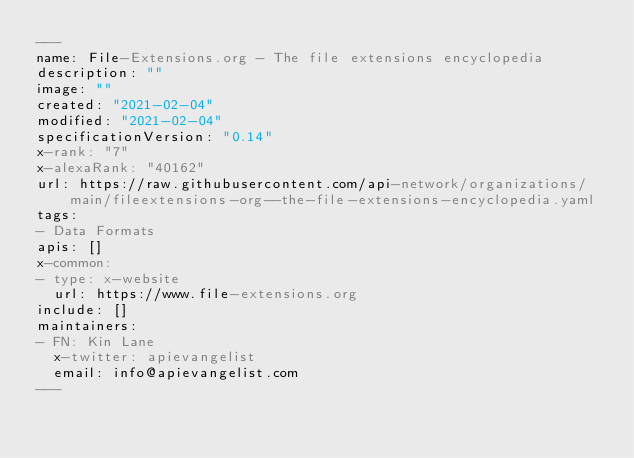<code> <loc_0><loc_0><loc_500><loc_500><_YAML_>---
name: File-Extensions.org - The file extensions encyclopedia
description: ""
image: ""
created: "2021-02-04"
modified: "2021-02-04"
specificationVersion: "0.14"
x-rank: "7"
x-alexaRank: "40162"
url: https://raw.githubusercontent.com/api-network/organizations/main/fileextensions-org--the-file-extensions-encyclopedia.yaml
tags:
- Data Formats
apis: []
x-common:
- type: x-website
  url: https://www.file-extensions.org
include: []
maintainers:
- FN: Kin Lane
  x-twitter: apievangelist
  email: info@apievangelist.com
---</code> 